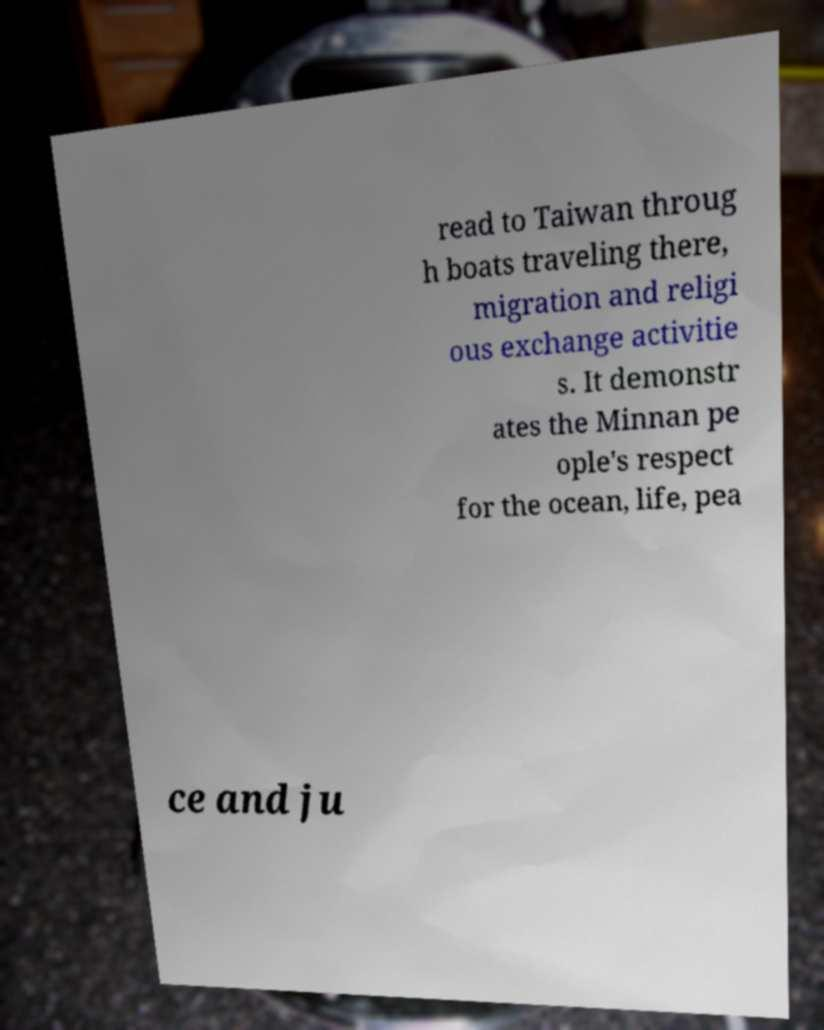Could you assist in decoding the text presented in this image and type it out clearly? read to Taiwan throug h boats traveling there, migration and religi ous exchange activitie s. It demonstr ates the Minnan pe ople's respect for the ocean, life, pea ce and ju 